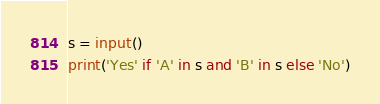Convert code to text. <code><loc_0><loc_0><loc_500><loc_500><_Python_>s = input()
print('Yes' if 'A' in s and 'B' in s else 'No')</code> 